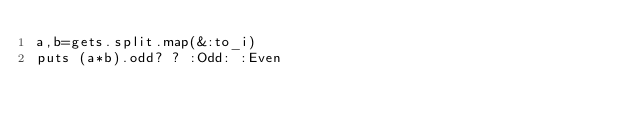<code> <loc_0><loc_0><loc_500><loc_500><_Ruby_>a,b=gets.split.map(&:to_i)
puts (a*b).odd? ? :Odd: :Even</code> 